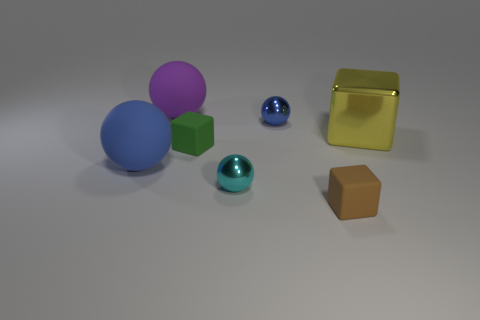Does the big sphere in front of the yellow object have the same color as the small shiny sphere behind the green thing?
Your answer should be very brief. Yes. The matte thing that is both in front of the green cube and left of the tiny brown matte cube is what color?
Your response must be concise. Blue. Do the rubber sphere that is behind the big blue matte object and the cube right of the brown thing have the same size?
Make the answer very short. Yes. How many other things are the same size as the purple object?
Offer a terse response. 2. How many green things are in front of the tiny metal sphere behind the small cyan thing?
Offer a terse response. 1. Are there fewer green things right of the small brown matte object than large purple matte spheres?
Keep it short and to the point. Yes. What is the shape of the tiny rubber thing that is behind the shiny thing left of the small shiny object that is right of the tiny cyan shiny ball?
Your response must be concise. Cube. Do the green matte object and the tiny brown rubber object have the same shape?
Keep it short and to the point. Yes. How many other objects are the same shape as the green rubber thing?
Your response must be concise. 2. There is a cube that is the same size as the green object; what color is it?
Your answer should be compact. Brown. 